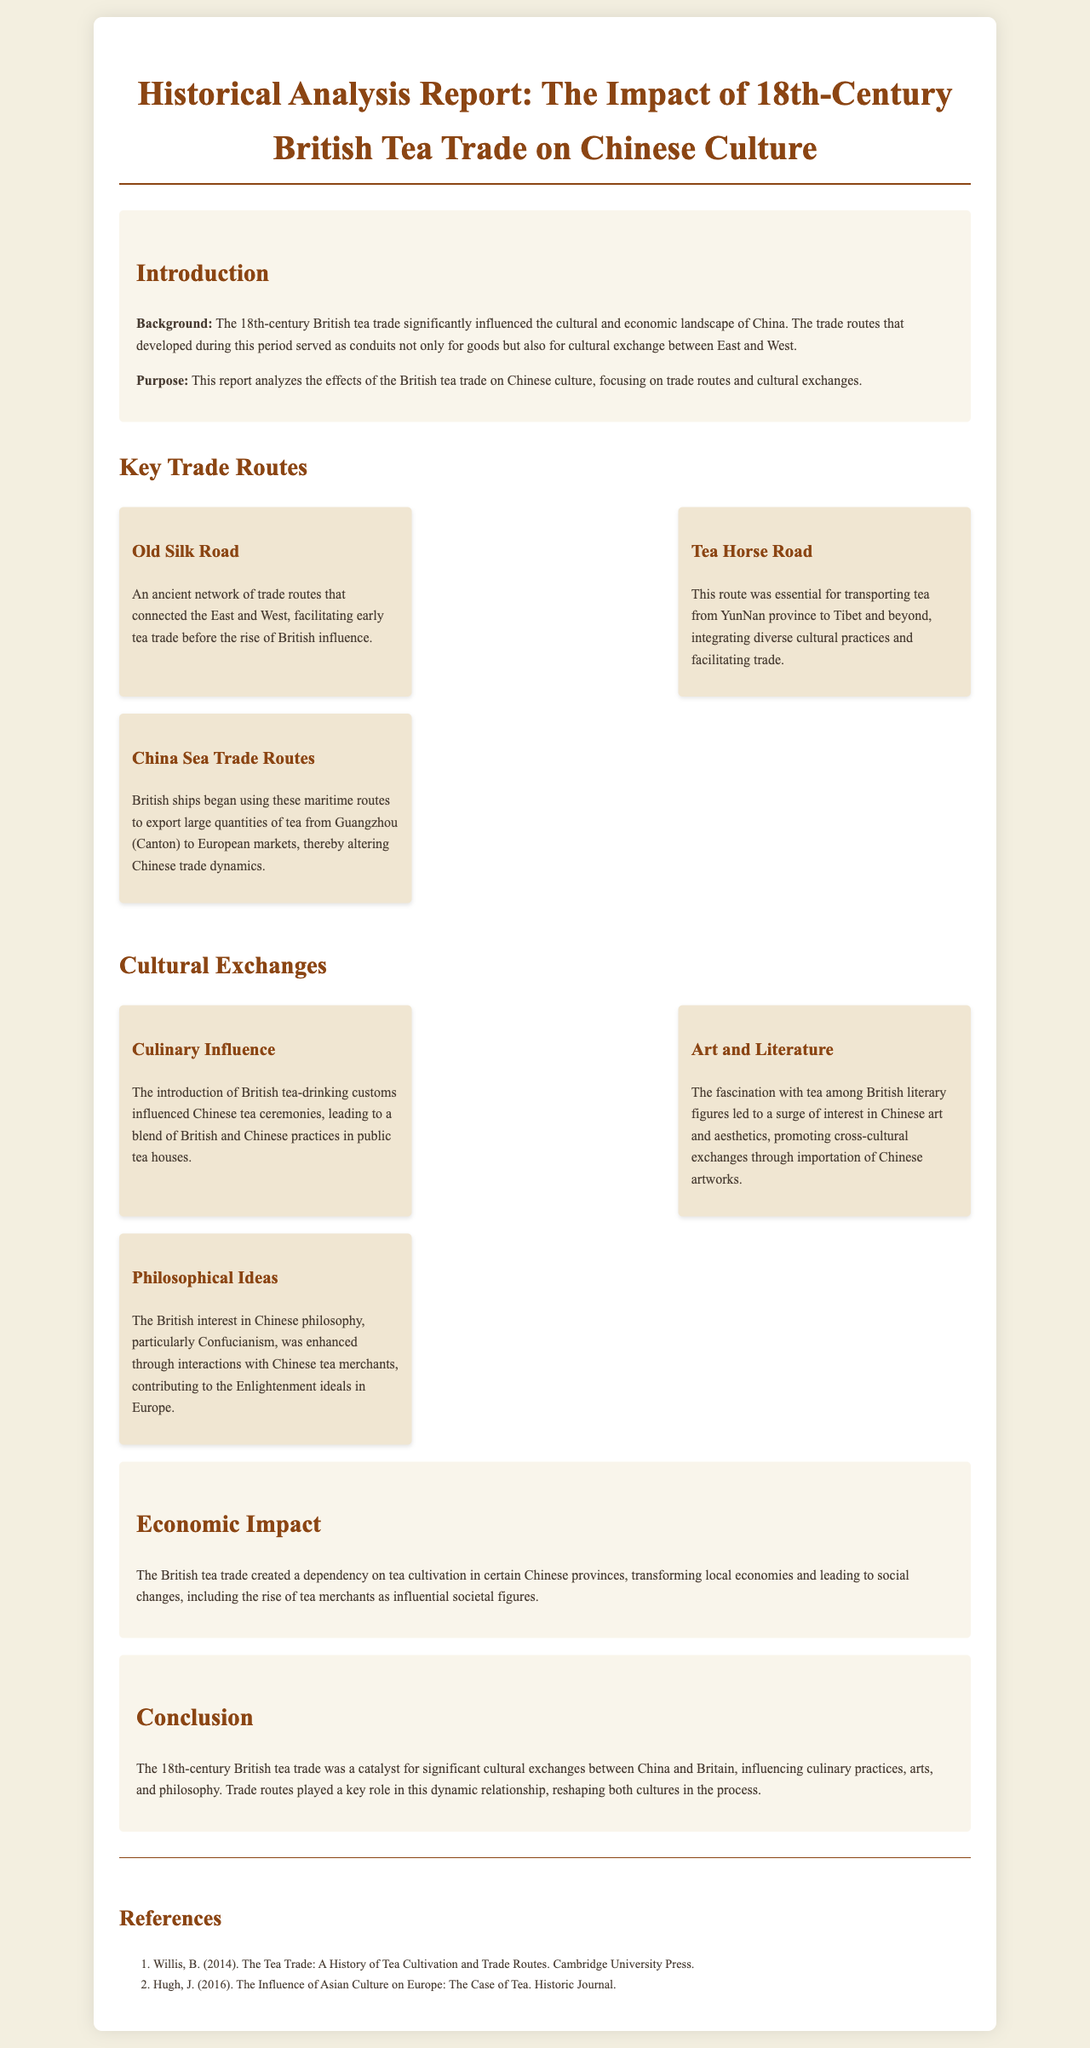What was the main purpose of the report? The report analyzes the effects of the British tea trade on Chinese culture, focusing on trade routes and cultural exchanges.
Answer: Analyzes effects of British tea trade on Chinese culture What is one of the key trade routes mentioned? The document lists three key trade routes in the section about Key Trade Routes.
Answer: Old Silk Road How did the British tea trade affect Chinese economic structure? The document states that the British tea trade created a dependency on tea cultivation in certain Chinese provinces.
Answer: Dependency on tea cultivation What culinary influence emerged from the British tea trade? The document explains that British tea-drinking customs influenced Chinese tea ceremonies.
Answer: Blend of British and Chinese practices What was a cultural exchange related to art? The document highlights that the fascination with tea among British literary figures promoted cross-cultural exchanges through importation of Chinese artworks.
Answer: Importation of Chinese artworks What was one philosophical idea exchanged during the tea trade? The document specifies that the British interest in Confucianism was enhanced through interactions with Chinese tea merchants.
Answer: Confucianism Which ancient trade route is mentioned as facilitating early tea trade? The text refers to the Old Silk Road as an ancient network of trade routes.
Answer: Old Silk Road What impact did the tea trade have on social structures in China? The report notes that the tea trade led to the rise of tea merchants as influential societal figures.
Answer: Rise of tea merchants Who is one author referenced in the document? The references section lists authors related to the British tea trade and its cultural implications.
Answer: Willis, B 